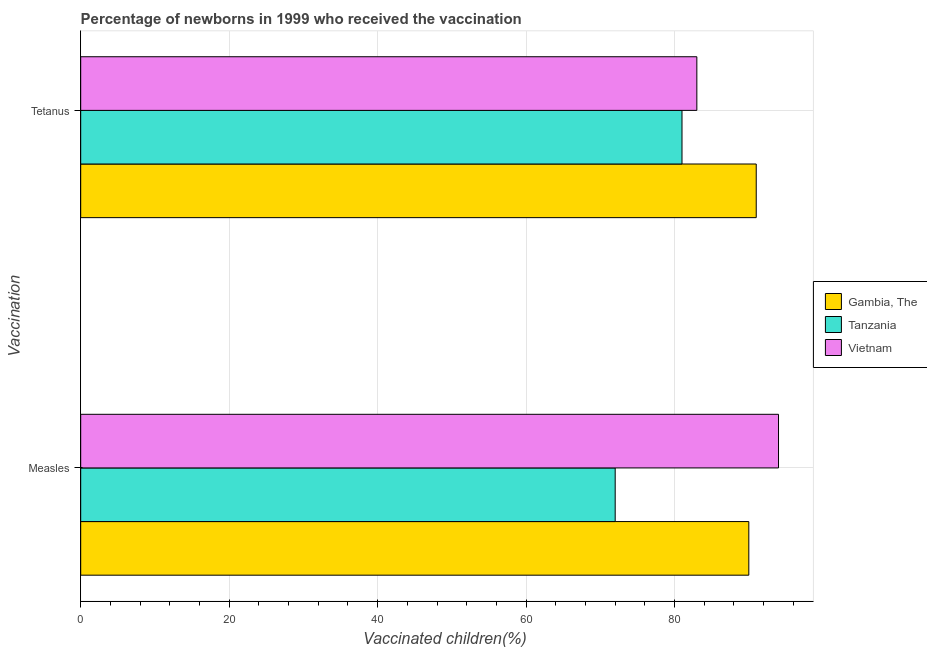How many groups of bars are there?
Your answer should be compact. 2. How many bars are there on the 1st tick from the bottom?
Your answer should be compact. 3. What is the label of the 1st group of bars from the top?
Your answer should be compact. Tetanus. What is the percentage of newborns who received vaccination for measles in Gambia, The?
Your response must be concise. 90. Across all countries, what is the maximum percentage of newborns who received vaccination for measles?
Offer a terse response. 94. Across all countries, what is the minimum percentage of newborns who received vaccination for tetanus?
Provide a succinct answer. 81. In which country was the percentage of newborns who received vaccination for measles maximum?
Give a very brief answer. Vietnam. In which country was the percentage of newborns who received vaccination for measles minimum?
Provide a short and direct response. Tanzania. What is the total percentage of newborns who received vaccination for measles in the graph?
Make the answer very short. 256. What is the difference between the percentage of newborns who received vaccination for measles in Gambia, The and that in Tanzania?
Offer a terse response. 18. What is the difference between the percentage of newborns who received vaccination for tetanus in Vietnam and the percentage of newborns who received vaccination for measles in Tanzania?
Provide a short and direct response. 11. What is the average percentage of newborns who received vaccination for measles per country?
Keep it short and to the point. 85.33. What is the difference between the percentage of newborns who received vaccination for measles and percentage of newborns who received vaccination for tetanus in Tanzania?
Your answer should be very brief. -9. In how many countries, is the percentage of newborns who received vaccination for tetanus greater than 8 %?
Your answer should be compact. 3. What is the ratio of the percentage of newborns who received vaccination for tetanus in Gambia, The to that in Tanzania?
Your response must be concise. 1.12. Is the percentage of newborns who received vaccination for tetanus in Tanzania less than that in Gambia, The?
Provide a succinct answer. Yes. In how many countries, is the percentage of newborns who received vaccination for tetanus greater than the average percentage of newborns who received vaccination for tetanus taken over all countries?
Your response must be concise. 1. What does the 1st bar from the top in Tetanus represents?
Offer a terse response. Vietnam. What does the 2nd bar from the bottom in Measles represents?
Keep it short and to the point. Tanzania. How many countries are there in the graph?
Your answer should be very brief. 3. Are the values on the major ticks of X-axis written in scientific E-notation?
Give a very brief answer. No. Does the graph contain grids?
Ensure brevity in your answer.  Yes. How are the legend labels stacked?
Keep it short and to the point. Vertical. What is the title of the graph?
Ensure brevity in your answer.  Percentage of newborns in 1999 who received the vaccination. Does "Chad" appear as one of the legend labels in the graph?
Offer a terse response. No. What is the label or title of the X-axis?
Keep it short and to the point. Vaccinated children(%)
. What is the label or title of the Y-axis?
Ensure brevity in your answer.  Vaccination. What is the Vaccinated children(%)
 of Vietnam in Measles?
Offer a terse response. 94. What is the Vaccinated children(%)
 of Gambia, The in Tetanus?
Your response must be concise. 91. What is the Vaccinated children(%)
 in Tanzania in Tetanus?
Your response must be concise. 81. Across all Vaccination, what is the maximum Vaccinated children(%)
 in Gambia, The?
Your response must be concise. 91. Across all Vaccination, what is the maximum Vaccinated children(%)
 in Tanzania?
Give a very brief answer. 81. Across all Vaccination, what is the maximum Vaccinated children(%)
 in Vietnam?
Ensure brevity in your answer.  94. What is the total Vaccinated children(%)
 in Gambia, The in the graph?
Ensure brevity in your answer.  181. What is the total Vaccinated children(%)
 in Tanzania in the graph?
Keep it short and to the point. 153. What is the total Vaccinated children(%)
 of Vietnam in the graph?
Keep it short and to the point. 177. What is the difference between the Vaccinated children(%)
 in Gambia, The in Measles and that in Tetanus?
Your response must be concise. -1. What is the difference between the Vaccinated children(%)
 of Vietnam in Measles and that in Tetanus?
Provide a succinct answer. 11. What is the difference between the Vaccinated children(%)
 in Gambia, The in Measles and the Vaccinated children(%)
 in Vietnam in Tetanus?
Provide a succinct answer. 7. What is the difference between the Vaccinated children(%)
 in Tanzania in Measles and the Vaccinated children(%)
 in Vietnam in Tetanus?
Your answer should be very brief. -11. What is the average Vaccinated children(%)
 of Gambia, The per Vaccination?
Make the answer very short. 90.5. What is the average Vaccinated children(%)
 of Tanzania per Vaccination?
Give a very brief answer. 76.5. What is the average Vaccinated children(%)
 of Vietnam per Vaccination?
Ensure brevity in your answer.  88.5. What is the difference between the Vaccinated children(%)
 in Gambia, The and Vaccinated children(%)
 in Tanzania in Measles?
Your answer should be compact. 18. What is the difference between the Vaccinated children(%)
 in Gambia, The and Vaccinated children(%)
 in Tanzania in Tetanus?
Provide a succinct answer. 10. What is the difference between the Vaccinated children(%)
 of Gambia, The and Vaccinated children(%)
 of Vietnam in Tetanus?
Keep it short and to the point. 8. What is the difference between the Vaccinated children(%)
 in Tanzania and Vaccinated children(%)
 in Vietnam in Tetanus?
Keep it short and to the point. -2. What is the ratio of the Vaccinated children(%)
 of Vietnam in Measles to that in Tetanus?
Give a very brief answer. 1.13. What is the difference between the highest and the second highest Vaccinated children(%)
 of Tanzania?
Provide a short and direct response. 9. What is the difference between the highest and the lowest Vaccinated children(%)
 of Gambia, The?
Offer a terse response. 1. What is the difference between the highest and the lowest Vaccinated children(%)
 of Tanzania?
Provide a short and direct response. 9. 